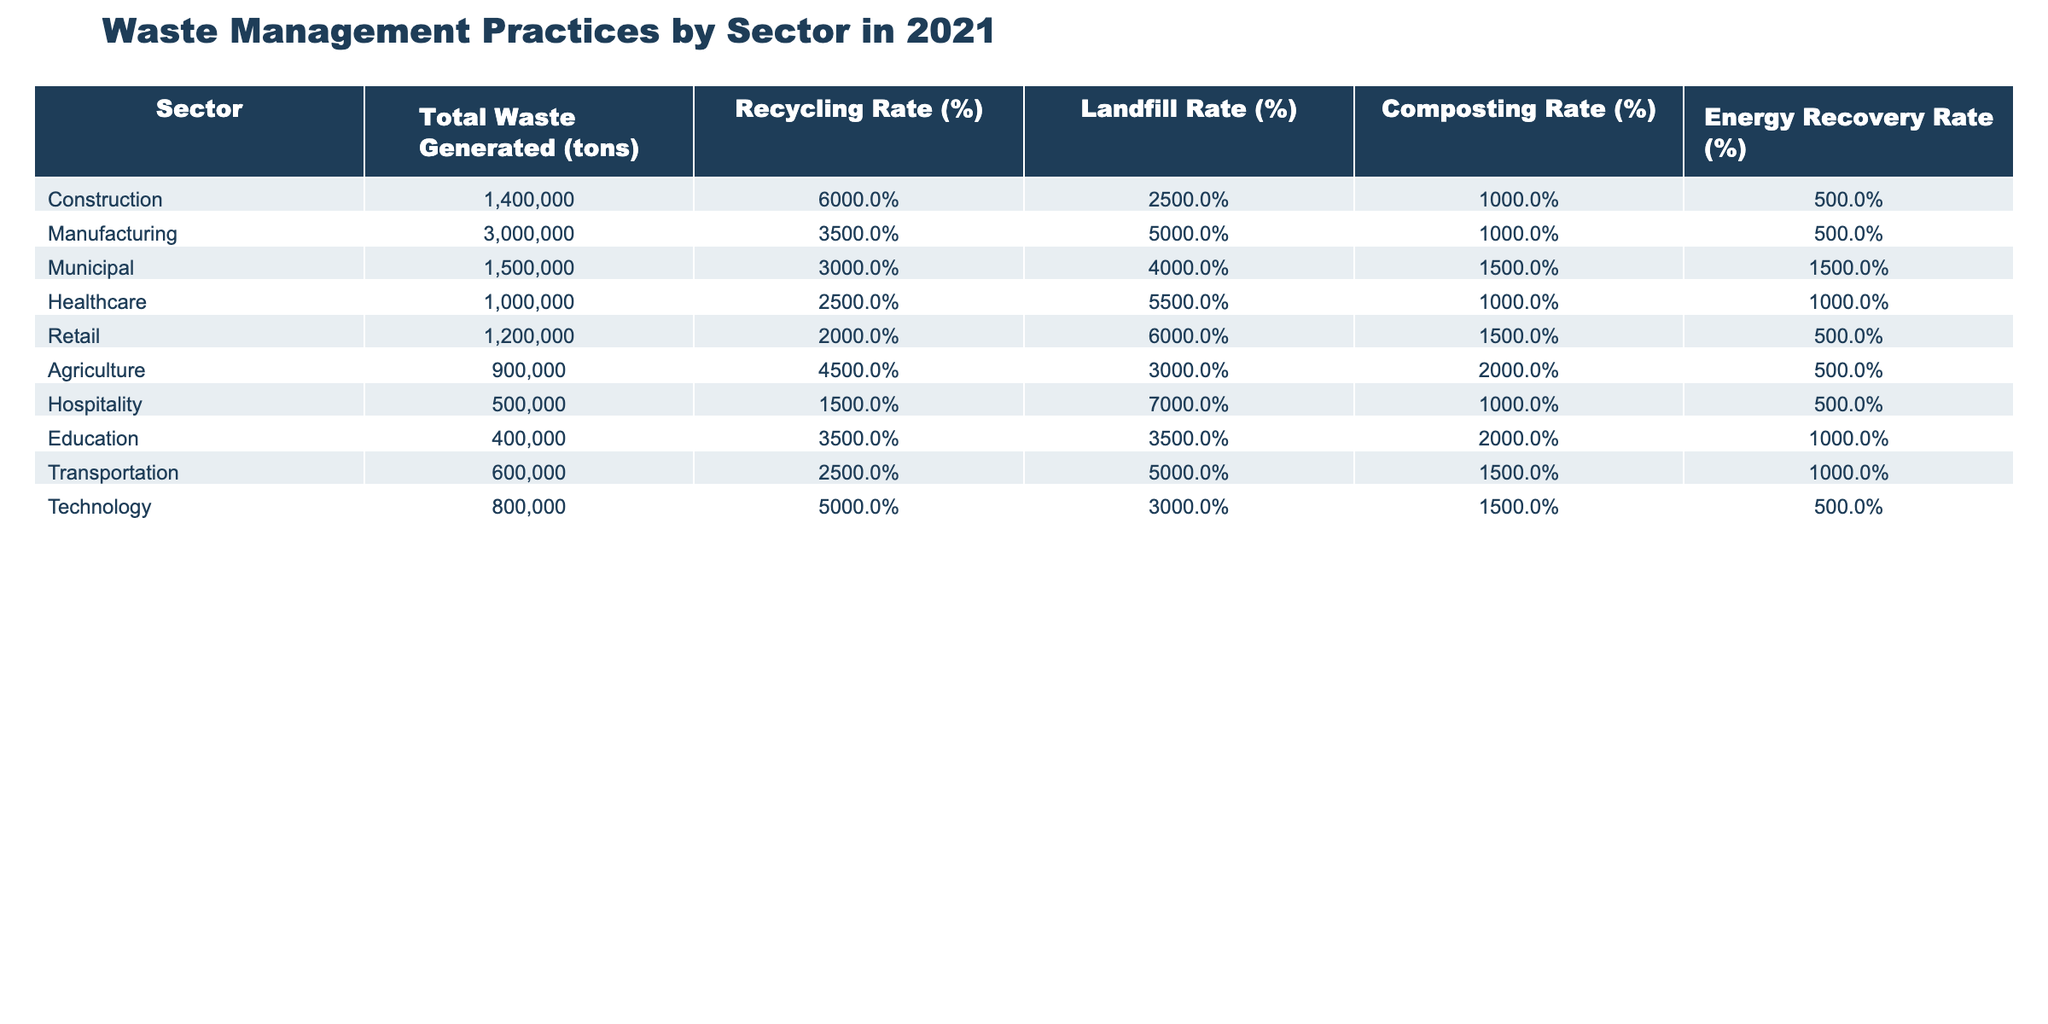What sector generated the most waste in 2021? The table shows that the Manufacturing sector generated the highest amount of waste at 3,000,000 tons.
Answer: Manufacturing What is the recycling rate for the Healthcare sector? According to the table, the Healthcare sector has a recycling rate of 25%.
Answer: 25% Which sector has the highest composting rate? The Agriculture sector has the highest composting rate at 20%.
Answer: Agriculture What is the total waste generated by the Construction sector? The Construction sector generated a total of 1,400,000 tons of waste in 2021.
Answer: 1,400,000 tons What percentage of waste generated in the Retail sector is sent to landfills? The Retail sector has a landfill rate of 60%.
Answer: 60% How does the composting rate of the Municipal sector compare to that of the Manufacturing sector? The Municipal sector composts 15% of its waste, while the Manufacturing sector composts 10%, which means the Municipal sector has a higher composting rate by 5%.
Answer: Higher by 5% Which sectors have a recycling rate above 40%? The Construction (60%), Agriculture (45%), and Technology (50%) sectors all have recycling rates above 40%.
Answer: Construction, Agriculture, Technology What is the average landfill rate across all sectors listed? The landfill rates are 25, 50, 40, 55, 60, 30, 70, 35, 50, and 30. Their total is 495. Dividing by the number of sectors (10) gives an average landfill rate of 49.5%.
Answer: 49.5% Is the energy recovery rate for the Hospitality sector above or below the average energy recovery rate? The Hospitality sector's energy recovery rate is 5%, and the total energy recovery rates for all sectors are 5, 5, 15, 10, 5, 5, 5, 10, and 5, averaging to 6.25%. The Hospitality sector is below the average.
Answer: Below What percentage difference in recycling rate is there between the Construction and Retail sectors? The Construction sector has a recycling rate of 60%, while the Retail sector has 20%. The difference is 60 - 20 = 40%.
Answer: 40% 